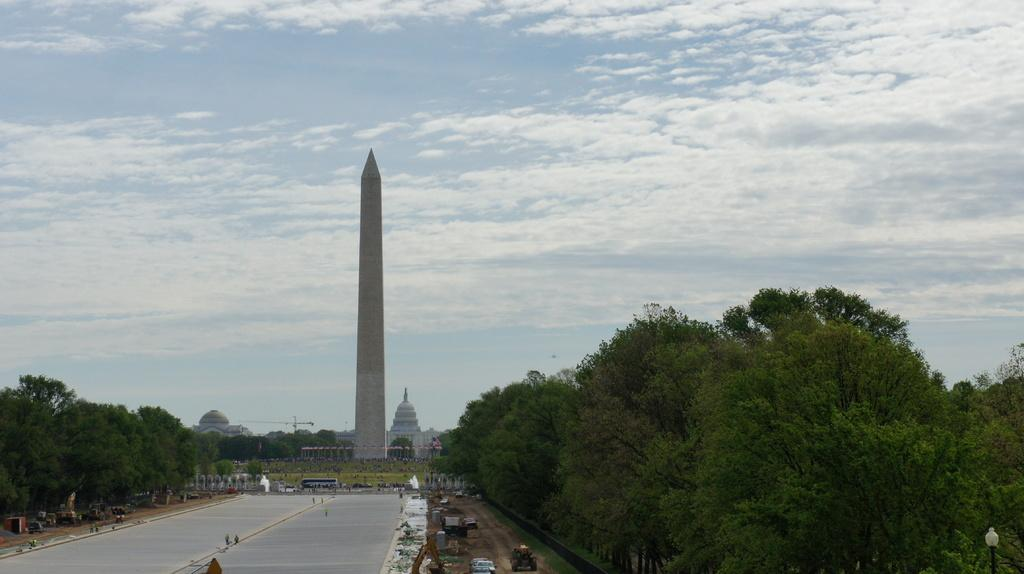What can be seen in the image? There are people, vehicles on the road, a tower, tombs, trees, and some objects in the image. Can you describe the setting of the image? The image shows a scene with people, vehicles, and a tower, along with tombs and trees. The sky is visible in the background, with clouds present. What might be the purpose of the tower in the image? The purpose of the tower in the image is not specified, but it could be a landmark, a watchtower, or part of a building. How many vehicles are visible on the road? The number of vehicles on the road is not specified, but there are vehicles present. What type of payment is being made in the image? There is no indication of any payment being made in the image. 